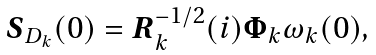Convert formula to latex. <formula><loc_0><loc_0><loc_500><loc_500>\boldsymbol S _ { D _ { k } } ( 0 ) = \boldsymbol R _ { k } ^ { - 1 / 2 } ( i ) \boldsymbol \Phi _ { k } \omega _ { k } ( 0 ) ,</formula> 